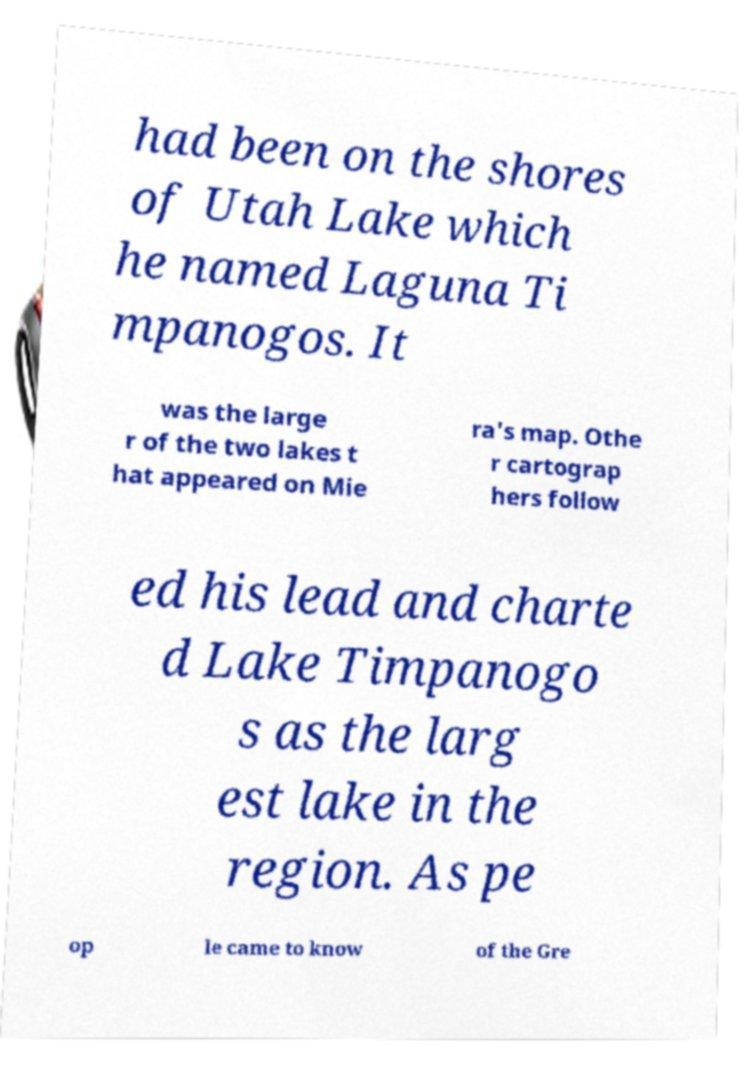What messages or text are displayed in this image? I need them in a readable, typed format. had been on the shores of Utah Lake which he named Laguna Ti mpanogos. It was the large r of the two lakes t hat appeared on Mie ra's map. Othe r cartograp hers follow ed his lead and charte d Lake Timpanogo s as the larg est lake in the region. As pe op le came to know of the Gre 